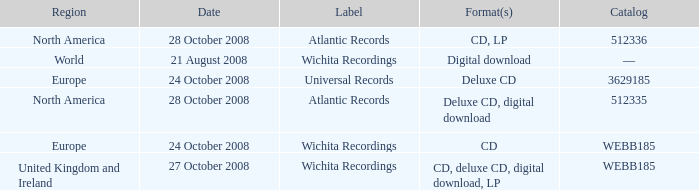Which date was associated with the release in Europe on the Wichita Recordings label? 24 October 2008. 